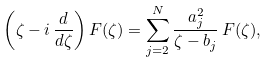<formula> <loc_0><loc_0><loc_500><loc_500>\left ( \zeta - i \, \frac { d } { d \zeta } \right ) F ( \zeta ) = \sum _ { j = 2 } ^ { N } \frac { a _ { j } ^ { 2 } } { \zeta - b _ { j } } \, F ( \zeta ) ,</formula> 